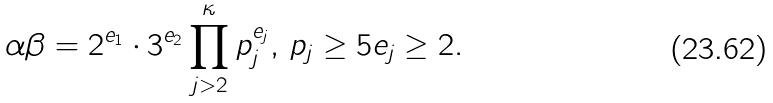Convert formula to latex. <formula><loc_0><loc_0><loc_500><loc_500>\alpha \beta = 2 ^ { e _ { 1 } } \cdot 3 ^ { e _ { 2 } } \, \underset { j > 2 } { \overset { \kappa } { \prod } } \, p _ { j } ^ { e _ { j } } , \, p _ { j } \geq 5 e _ { j } \geq 2 .</formula> 